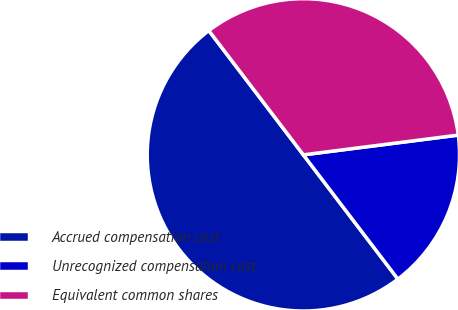Convert chart. <chart><loc_0><loc_0><loc_500><loc_500><pie_chart><fcel>Accrued compensation cost<fcel>Unrecognized compensation cost<fcel>Equivalent common shares<nl><fcel>50.0%<fcel>16.67%<fcel>33.33%<nl></chart> 